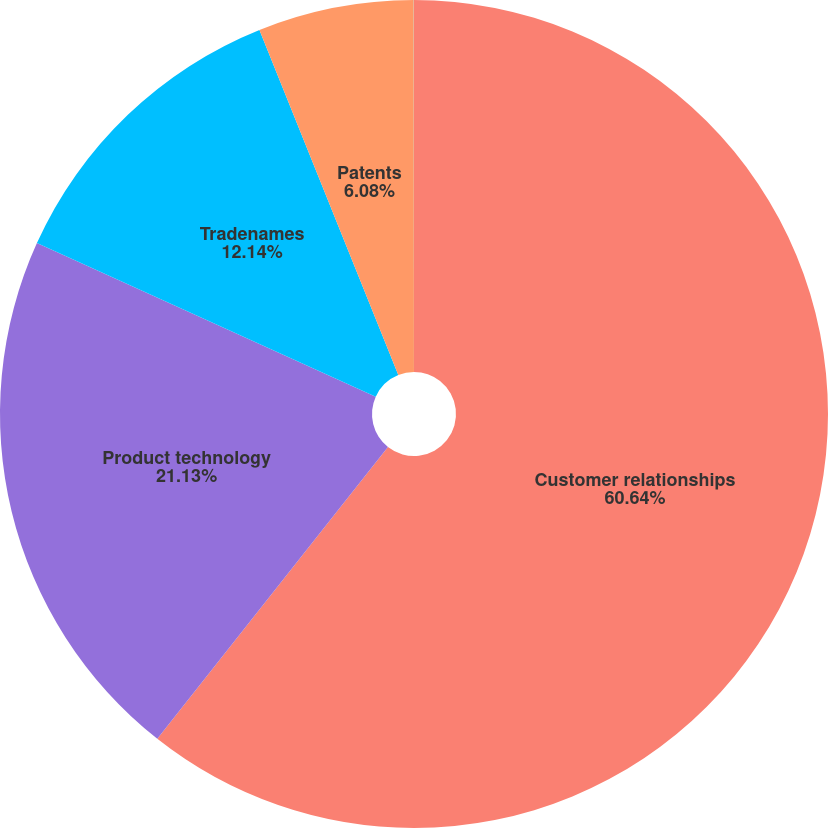Convert chart. <chart><loc_0><loc_0><loc_500><loc_500><pie_chart><fcel>Customer relationships<fcel>Product technology<fcel>Tradenames<fcel>Patents<fcel>Other<nl><fcel>60.65%<fcel>21.13%<fcel>12.14%<fcel>6.08%<fcel>0.01%<nl></chart> 